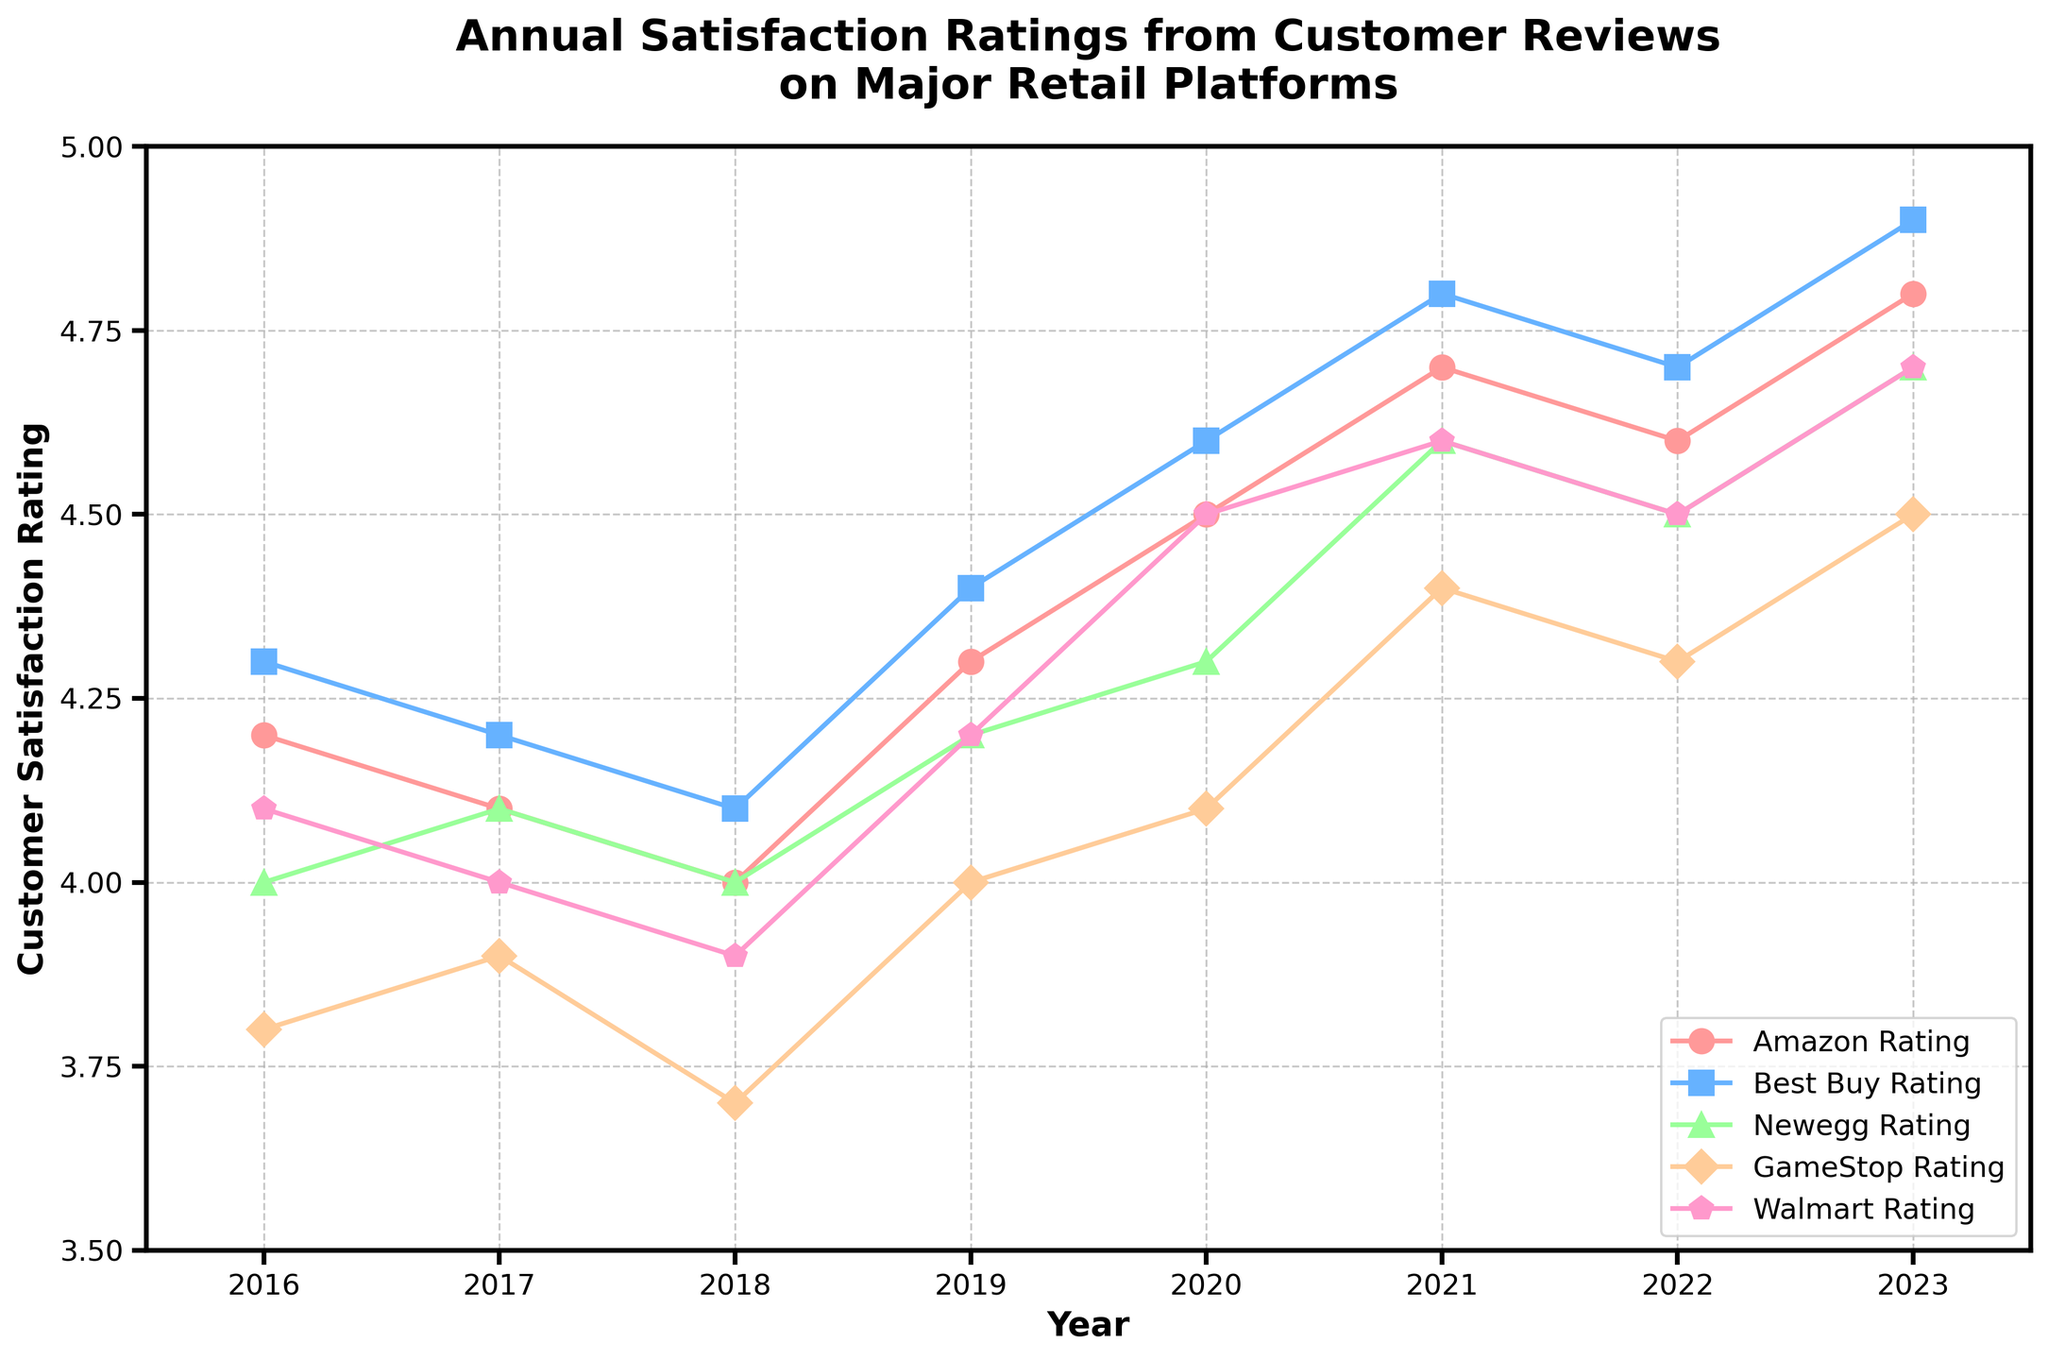What is the title of the plot? The title of the plot is usually the text at the top that summarizes the content. Here, it reads "Annual Satisfaction Ratings from Customer Reviews on Major Retail Platforms."
Answer: Annual Satisfaction Ratings from Customer Reviews on Major Retail Platforms Which retail platform had the highest satisfaction rating in 2023? By observing the data points for 2023, we can see that Best Buy has the highest rating, as it reaches 4.9.
Answer: Best Buy What was GameStop's rating in 2018? To find GameStop's rating in 2018, we look at the data point for GameStop in the year 2018. It is marked at 3.7.
Answer: 3.7 Did any platform's rating decrease from 2022 to 2023? By comparing the ratings from 2022 to 2023 for all platforms, we see that none of the platforms show a decrease; all ratings either remain stable or increase.
Answer: No Which year saw the highest overall increase in ratings for Amazon? Observing Amazon's rating changes over the years, the increase from 2018 to 2019 is the highest, rising by 0.3 units.
Answer: 2019 What is the average satisfaction rating for Newegg over the seven years shown? To calculate the average, we sum Newegg's ratings from 2016 to 2023 and divide by 7. The ratings are 4.0, 4.1, 4.0, 4.2, 4.3, 4.6, 4.5, 4.7. Sum = 33.4; Average = 33.4 / 7 = 4.77.
Answer: 4.77 How does Walmart's rating in 2020 compare to its rating in 2016? Walmart's rating in 2020 is 4.5, whereas in 2016 it was 4.1. Therefore, the rating increased by 0.4 units.
Answer: Increased by 0.4 Which platform has shown the most consistent (least variable) ratings over the years? The consistency of ratings can be measured by observing the fluctuations over the years. By visual inspection, Amazon shows the least variability with gradual small changes.
Answer: Amazon Between which two consecutive years did Best Buy show the largest increase in ratings? By comparing the differences between consecutive years for Best Buy, the largest increase is between 2018 (4.1) and 2019 (4.4), with an increase of 0.3 units.
Answer: 2018 and 2019 